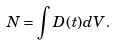Convert formula to latex. <formula><loc_0><loc_0><loc_500><loc_500>N = \int D ( t ) d V .</formula> 